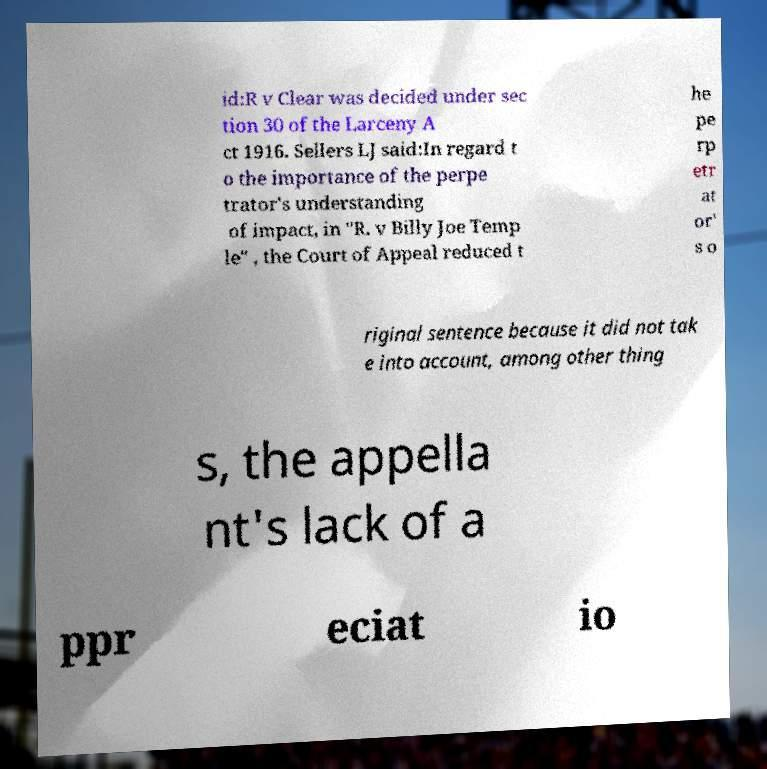For documentation purposes, I need the text within this image transcribed. Could you provide that? id:R v Clear was decided under sec tion 30 of the Larceny A ct 1916. Sellers LJ said:In regard t o the importance of the perpe trator's understanding of impact, in "R. v Billy Joe Temp le" , the Court of Appeal reduced t he pe rp etr at or' s o riginal sentence because it did not tak e into account, among other thing s, the appella nt's lack of a ppr eciat io 